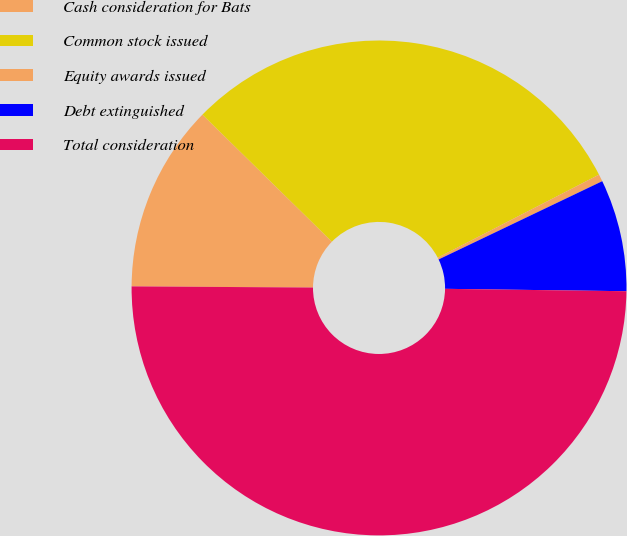Convert chart. <chart><loc_0><loc_0><loc_500><loc_500><pie_chart><fcel>Cash consideration for Bats<fcel>Common stock issued<fcel>Equity awards issued<fcel>Debt extinguished<fcel>Total consideration<nl><fcel>12.25%<fcel>30.08%<fcel>0.47%<fcel>7.31%<fcel>49.89%<nl></chart> 